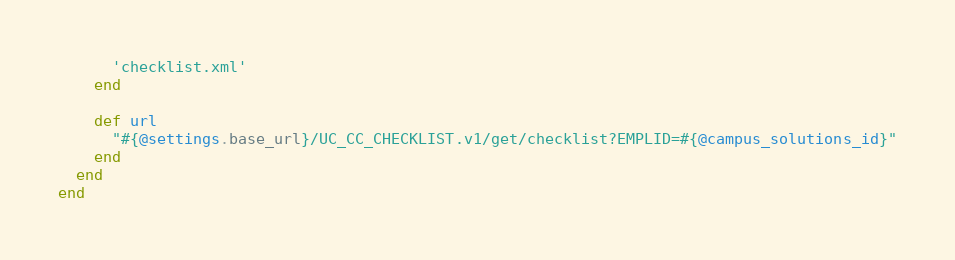Convert code to text. <code><loc_0><loc_0><loc_500><loc_500><_Ruby_>      'checklist.xml'
    end

    def url
      "#{@settings.base_url}/UC_CC_CHECKLIST.v1/get/checklist?EMPLID=#{@campus_solutions_id}"
    end
  end
end
</code> 